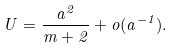Convert formula to latex. <formula><loc_0><loc_0><loc_500><loc_500>U = \frac { a ^ { 2 } } { m + 2 } + o ( a ^ { - 1 } ) .</formula> 